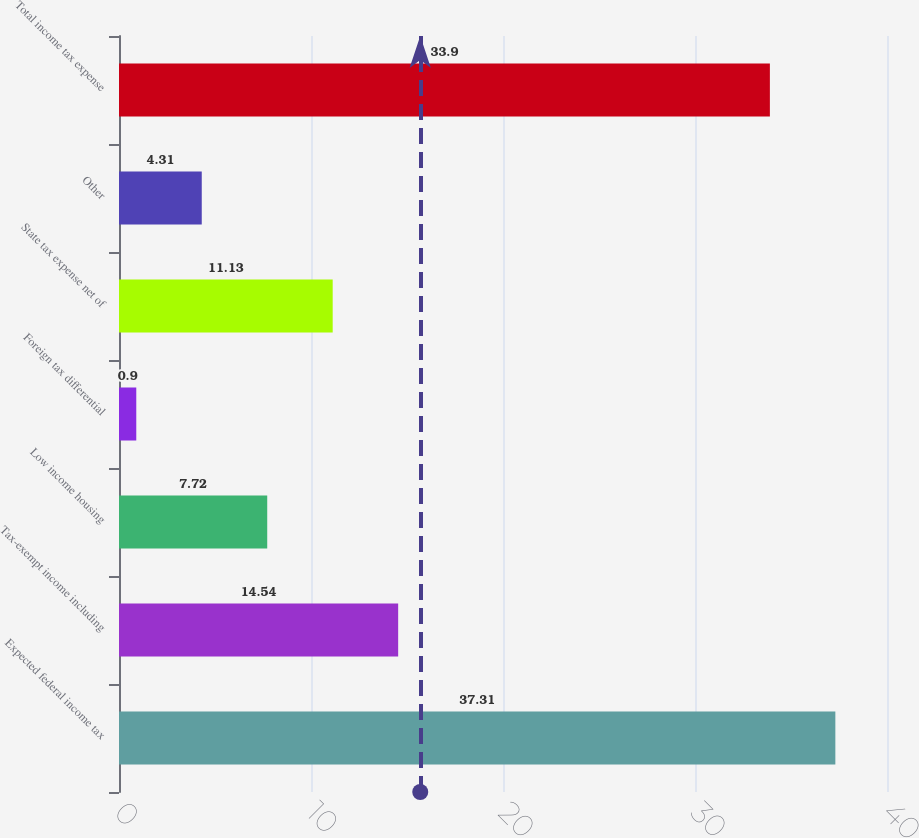<chart> <loc_0><loc_0><loc_500><loc_500><bar_chart><fcel>Expected federal income tax<fcel>Tax-exempt income including<fcel>Low income housing<fcel>Foreign tax differential<fcel>State tax expense net of<fcel>Other<fcel>Total income tax expense<nl><fcel>37.31<fcel>14.54<fcel>7.72<fcel>0.9<fcel>11.13<fcel>4.31<fcel>33.9<nl></chart> 